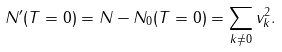Convert formula to latex. <formula><loc_0><loc_0><loc_500><loc_500>N ^ { \prime } ( T = 0 ) = N - N _ { 0 } ( T = 0 ) = \sum _ { k \neq 0 } v _ { k } ^ { 2 } .</formula> 